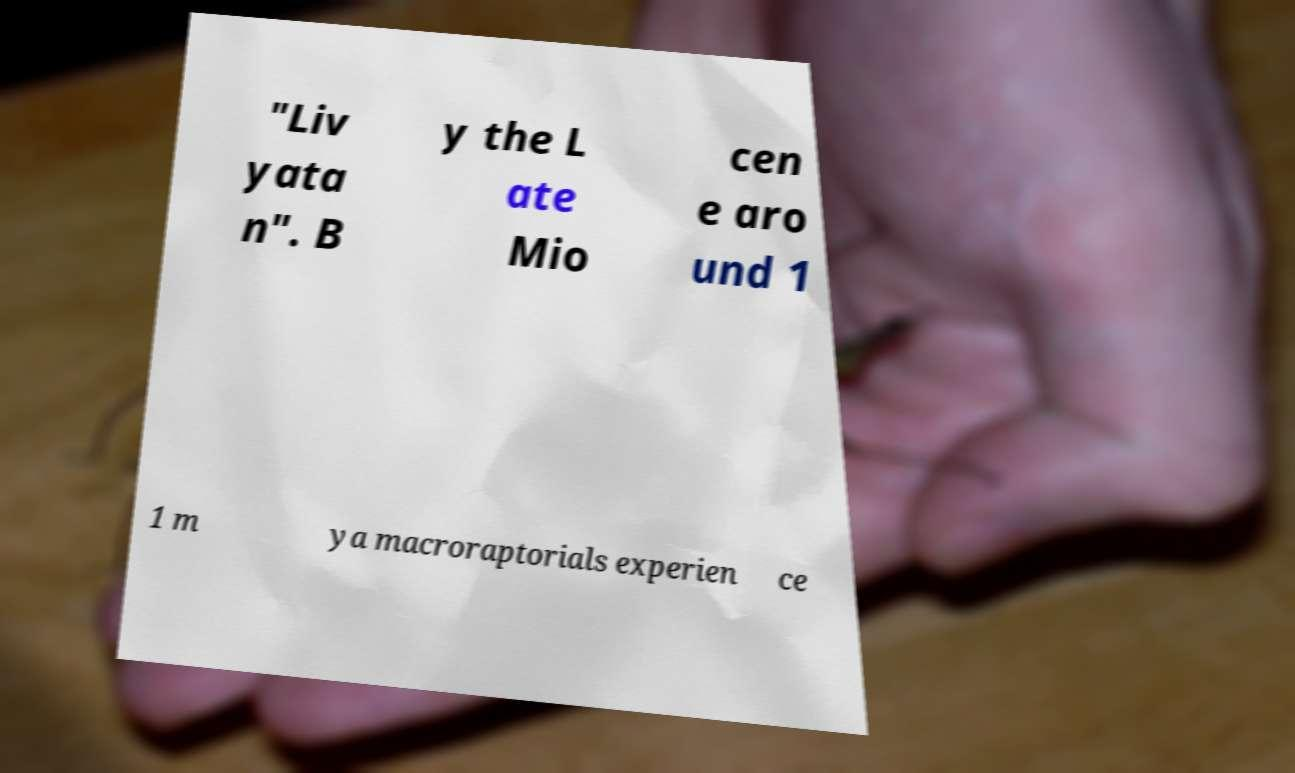What messages or text are displayed in this image? I need them in a readable, typed format. "Liv yata n". B y the L ate Mio cen e aro und 1 1 m ya macroraptorials experien ce 